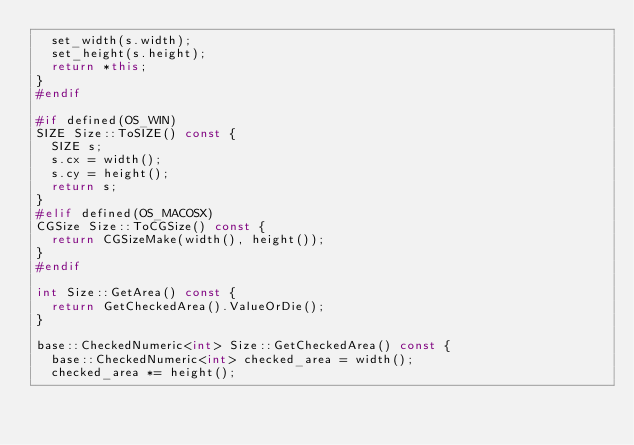Convert code to text. <code><loc_0><loc_0><loc_500><loc_500><_C++_>  set_width(s.width);
  set_height(s.height);
  return *this;
}
#endif

#if defined(OS_WIN)
SIZE Size::ToSIZE() const {
  SIZE s;
  s.cx = width();
  s.cy = height();
  return s;
}
#elif defined(OS_MACOSX)
CGSize Size::ToCGSize() const {
  return CGSizeMake(width(), height());
}
#endif

int Size::GetArea() const {
  return GetCheckedArea().ValueOrDie();
}

base::CheckedNumeric<int> Size::GetCheckedArea() const {
  base::CheckedNumeric<int> checked_area = width();
  checked_area *= height();</code> 